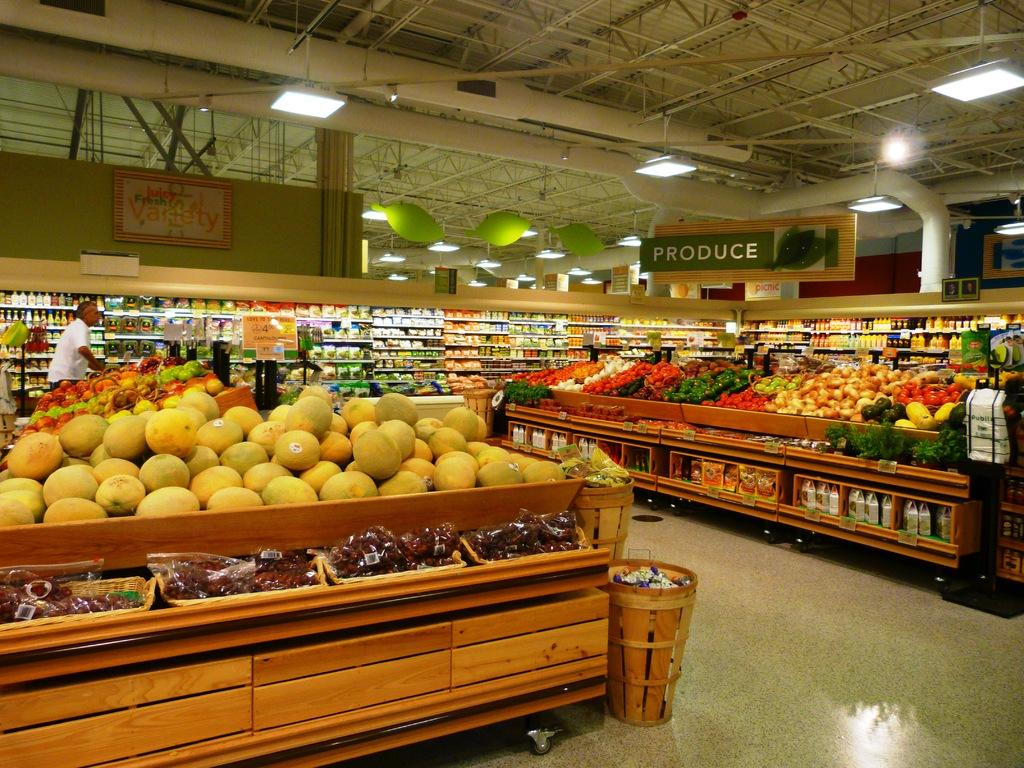Provide a one-sentence caption for the provided image. A grocery store full of produce with a sign above it. 